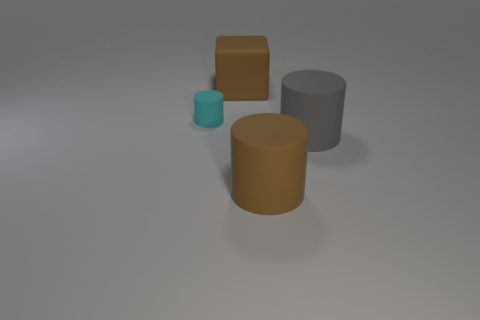There is another big object that is the same shape as the large gray object; what is its color?
Give a very brief answer. Brown. What is the shape of the brown rubber thing that is in front of the tiny cyan matte object?
Offer a very short reply. Cylinder. Are there any brown matte things in front of the large brown cube?
Provide a short and direct response. Yes. Is there anything else that has the same size as the cyan cylinder?
Give a very brief answer. No. What is the color of the small thing that is the same material as the big brown cube?
Provide a short and direct response. Cyan. Does the big object behind the small matte thing have the same color as the cylinder left of the large brown block?
Provide a short and direct response. No. How many cylinders are either brown metallic objects or small matte things?
Provide a succinct answer. 1. Is the number of blocks that are left of the cyan cylinder the same as the number of large rubber objects?
Your answer should be compact. No. What is the brown object that is behind the cyan cylinder to the left of the big cylinder to the left of the gray object made of?
Keep it short and to the point. Rubber. There is a large thing that is the same color as the big block; what material is it?
Your response must be concise. Rubber. 